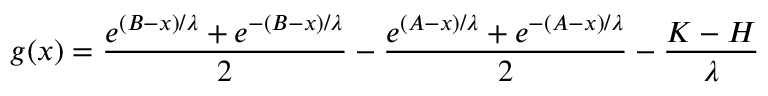<formula> <loc_0><loc_0><loc_500><loc_500>g ( x ) = \frac { e ^ { ( B - x ) / \lambda } + e ^ { - ( B - x ) / \lambda } } { 2 } - \frac { e ^ { ( A - x ) / \lambda } + e ^ { - ( A - x ) / \lambda } } { 2 } - \frac { K - H } { \lambda }</formula> 